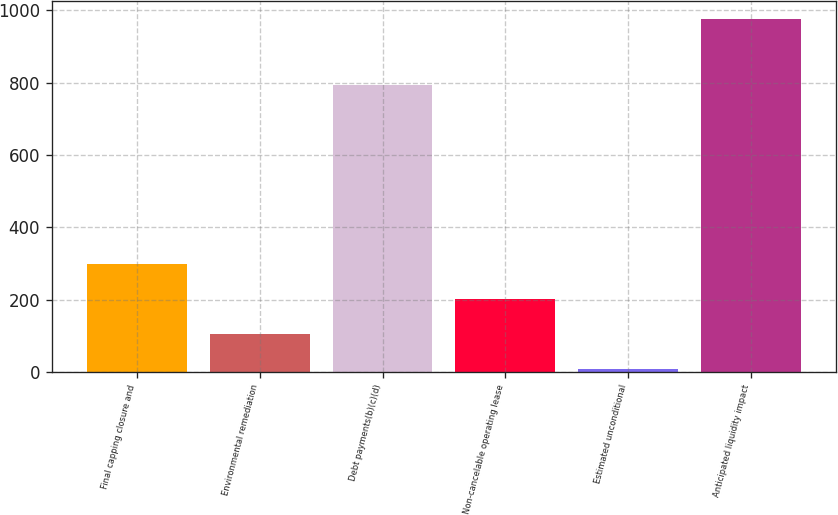<chart> <loc_0><loc_0><loc_500><loc_500><bar_chart><fcel>Final capping closure and<fcel>Environmental remediation<fcel>Debt payments(b)(c)(d)<fcel>Non-cancelable operating lease<fcel>Estimated unconditional<fcel>Anticipated liquidity impact<nl><fcel>299.4<fcel>105.8<fcel>793<fcel>202.6<fcel>9<fcel>977<nl></chart> 